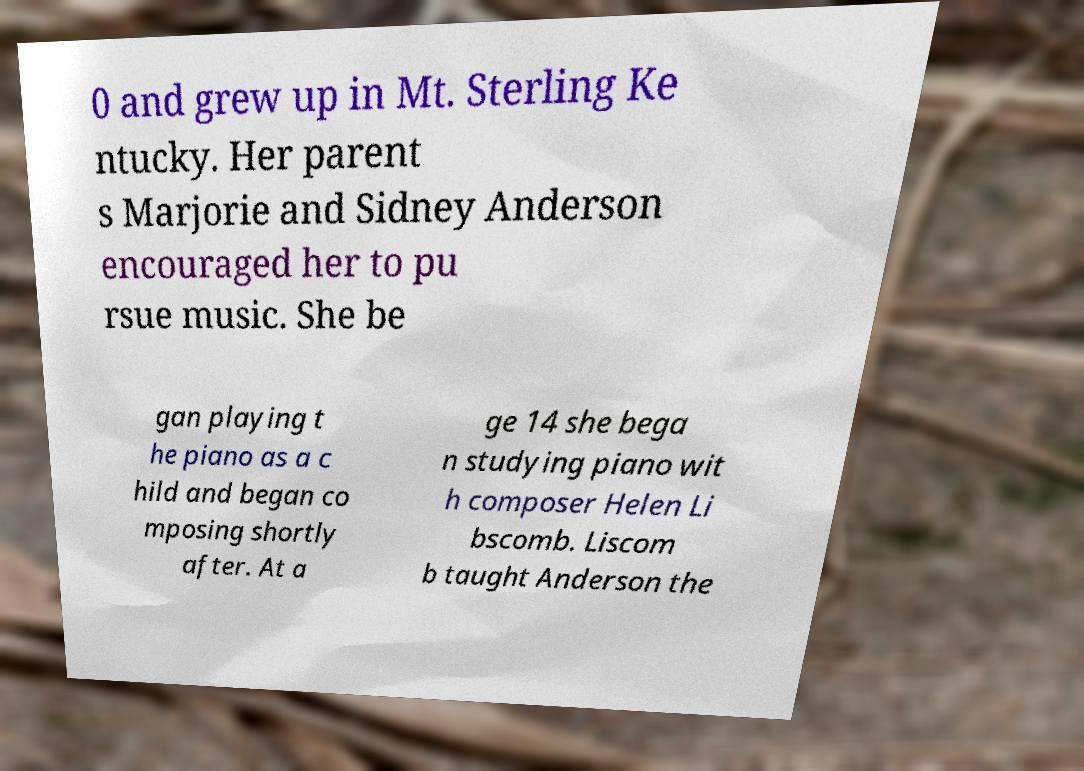Please identify and transcribe the text found in this image. 0 and grew up in Mt. Sterling Ke ntucky. Her parent s Marjorie and Sidney Anderson encouraged her to pu rsue music. She be gan playing t he piano as a c hild and began co mposing shortly after. At a ge 14 she bega n studying piano wit h composer Helen Li bscomb. Liscom b taught Anderson the 